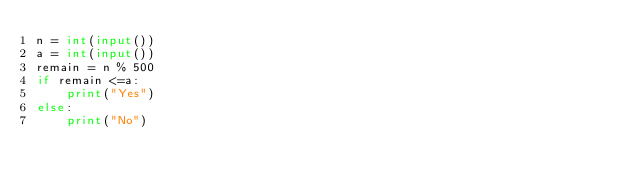Convert code to text. <code><loc_0><loc_0><loc_500><loc_500><_Python_>n = int(input())
a = int(input())
remain = n % 500
if remain <=a:
    print("Yes")
else:
    print("No")</code> 